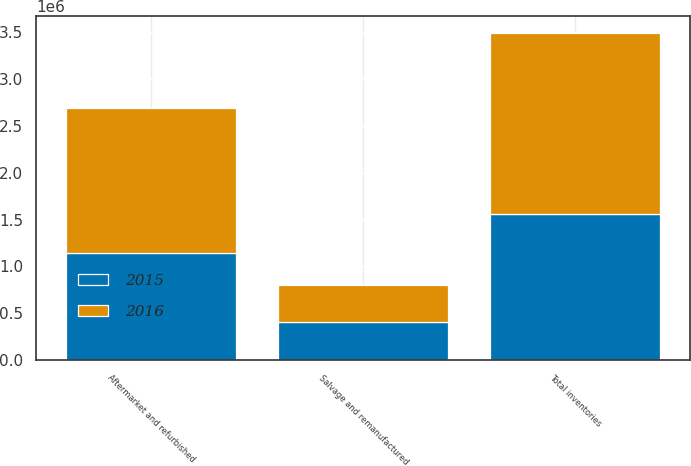<chart> <loc_0><loc_0><loc_500><loc_500><stacked_bar_chart><ecel><fcel>Aftermarket and refurbished<fcel>Salvage and remanufactured<fcel>Total inventories<nl><fcel>2016<fcel>1.54026e+06<fcel>394980<fcel>1.93524e+06<nl><fcel>2015<fcel>1.14616e+06<fcel>410390<fcel>1.55655e+06<nl></chart> 